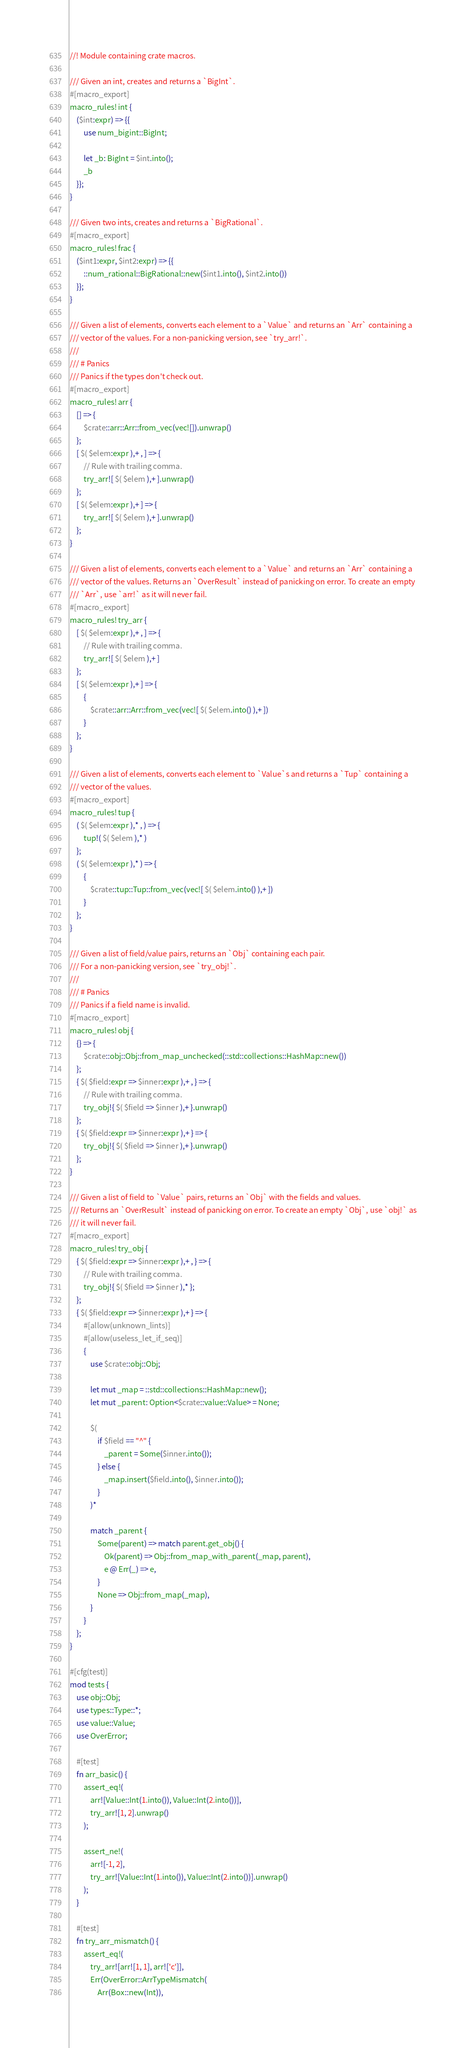<code> <loc_0><loc_0><loc_500><loc_500><_Rust_>//! Module containing crate macros.

/// Given an int, creates and returns a `BigInt`.
#[macro_export]
macro_rules! int {
    ($int:expr) => {{
        use num_bigint::BigInt;

        let _b: BigInt = $int.into();
        _b
    }};
}

/// Given two ints, creates and returns a `BigRational`.
#[macro_export]
macro_rules! frac {
    ($int1:expr, $int2:expr) => {{
        ::num_rational::BigRational::new($int1.into(), $int2.into())
    }};
}

/// Given a list of elements, converts each element to a `Value` and returns an `Arr` containing a
/// vector of the values. For a non-panicking version, see `try_arr!`.
///
/// # Panics
/// Panics if the types don't check out.
#[macro_export]
macro_rules! arr {
    [] => {
        $crate::arr::Arr::from_vec(vec![]).unwrap()
    };
    [ $( $elem:expr ),+ , ] => {
        // Rule with trailing comma.
        try_arr![ $( $elem ),+ ].unwrap()
    };
    [ $( $elem:expr ),+ ] => {
        try_arr![ $( $elem ),+ ].unwrap()
    };
}

/// Given a list of elements, converts each element to a `Value` and returns an `Arr` containing a
/// vector of the values. Returns an `OverResult` instead of panicking on error. To create an empty
/// `Arr`, use `arr!` as it will never fail.
#[macro_export]
macro_rules! try_arr {
    [ $( $elem:expr ),+ , ] => {
        // Rule with trailing comma.
        try_arr![ $( $elem ),+ ]
    };
    [ $( $elem:expr ),+ ] => {
        {
            $crate::arr::Arr::from_vec(vec![ $( $elem.into() ),+ ])
        }
    };
}

/// Given a list of elements, converts each element to `Value`s and returns a `Tup` containing a
/// vector of the values.
#[macro_export]
macro_rules! tup {
    ( $( $elem:expr ),* , ) => {
        tup!( $( $elem ),* )
    };
    ( $( $elem:expr ),* ) => {
        {
            $crate::tup::Tup::from_vec(vec![ $( $elem.into() ),+ ])
        }
    };
}

/// Given a list of field/value pairs, returns an `Obj` containing each pair.
/// For a non-panicking version, see `try_obj!`.
///
/// # Panics
/// Panics if a field name is invalid.
#[macro_export]
macro_rules! obj {
    {} => {
        $crate::obj::Obj::from_map_unchecked(::std::collections::HashMap::new())
    };
    { $( $field:expr => $inner:expr ),+ , } => {
        // Rule with trailing comma.
        try_obj!{ $( $field => $inner ),+ }.unwrap()
    };
    { $( $field:expr => $inner:expr ),+ } => {
        try_obj!{ $( $field => $inner ),+ }.unwrap()
    };
}

/// Given a list of field to `Value` pairs, returns an `Obj` with the fields and values.
/// Returns an `OverResult` instead of panicking on error. To create an empty `Obj`, use `obj!` as
/// it will never fail.
#[macro_export]
macro_rules! try_obj {
    { $( $field:expr => $inner:expr ),+ , } => {
        // Rule with trailing comma.
        try_obj!{ $( $field => $inner ),* };
    };
    { $( $field:expr => $inner:expr ),+ } => {
        #[allow(unknown_lints)]
        #[allow(useless_let_if_seq)]
        {
            use $crate::obj::Obj;

            let mut _map = ::std::collections::HashMap::new();
            let mut _parent: Option<$crate::value::Value> = None;

            $(
                if $field == "^" {
                    _parent = Some($inner.into());
                } else {
                    _map.insert($field.into(), $inner.into());
                }
            )*

            match _parent {
                Some(parent) => match parent.get_obj() {
                    Ok(parent) => Obj::from_map_with_parent(_map, parent),
                    e @ Err(_) => e,
                }
                None => Obj::from_map(_map),
            }
        }
    };
}

#[cfg(test)]
mod tests {
    use obj::Obj;
    use types::Type::*;
    use value::Value;
    use OverError;

    #[test]
    fn arr_basic() {
        assert_eq!(
            arr![Value::Int(1.into()), Value::Int(2.into())],
            try_arr![1, 2].unwrap()
        );

        assert_ne!(
            arr![-1, 2],
            try_arr![Value::Int(1.into()), Value::Int(2.into())].unwrap()
        );
    }

    #[test]
    fn try_arr_mismatch() {
        assert_eq!(
            try_arr![arr![1, 1], arr!['c']],
            Err(OverError::ArrTypeMismatch(
                Arr(Box::new(Int)),</code> 